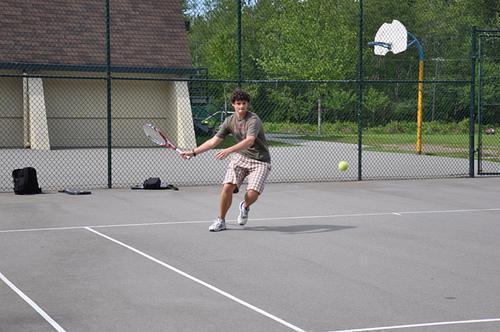How many balls in the picture?
Give a very brief answer. 1. How many people?
Give a very brief answer. 1. How many pieces of meat does the sandwich have?
Give a very brief answer. 0. 